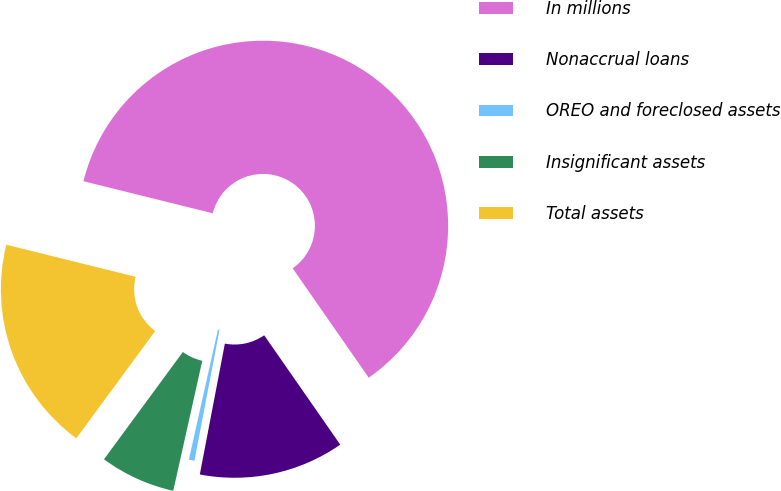Convert chart. <chart><loc_0><loc_0><loc_500><loc_500><pie_chart><fcel>In millions<fcel>Nonaccrual loans<fcel>OREO and foreclosed assets<fcel>Insignificant assets<fcel>Total assets<nl><fcel>61.46%<fcel>12.68%<fcel>0.49%<fcel>6.59%<fcel>18.78%<nl></chart> 